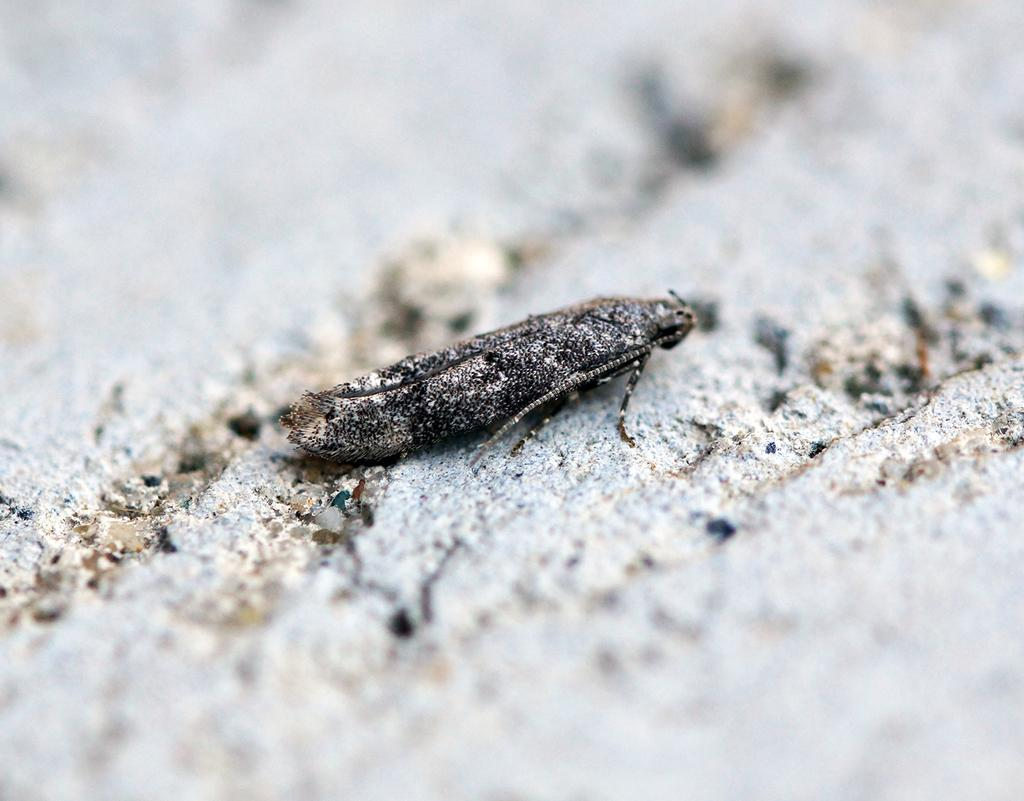What type of creature can be seen in the image? There is an insect in the image. What type of clover is the insect eating in the image? There is no clover present in the image, and the insect's actions are not described. 